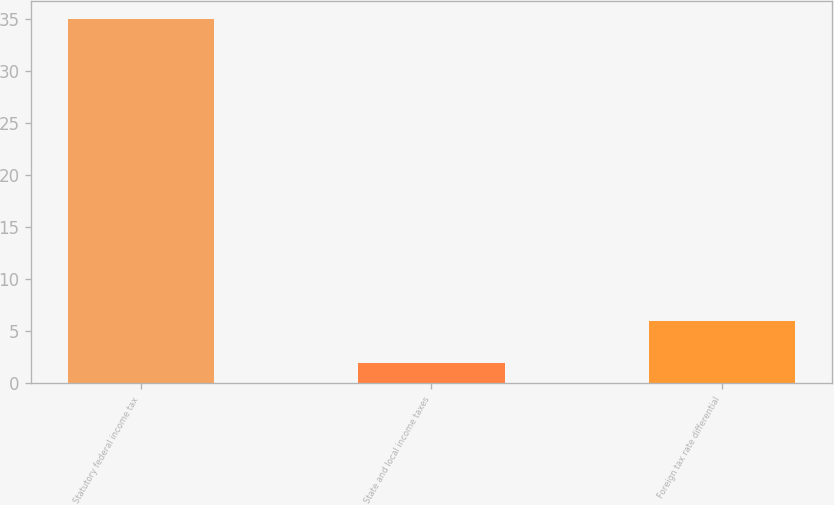Convert chart. <chart><loc_0><loc_0><loc_500><loc_500><bar_chart><fcel>Statutory federal income tax<fcel>State and local income taxes<fcel>Foreign tax rate differential<nl><fcel>35<fcel>2<fcel>6<nl></chart> 